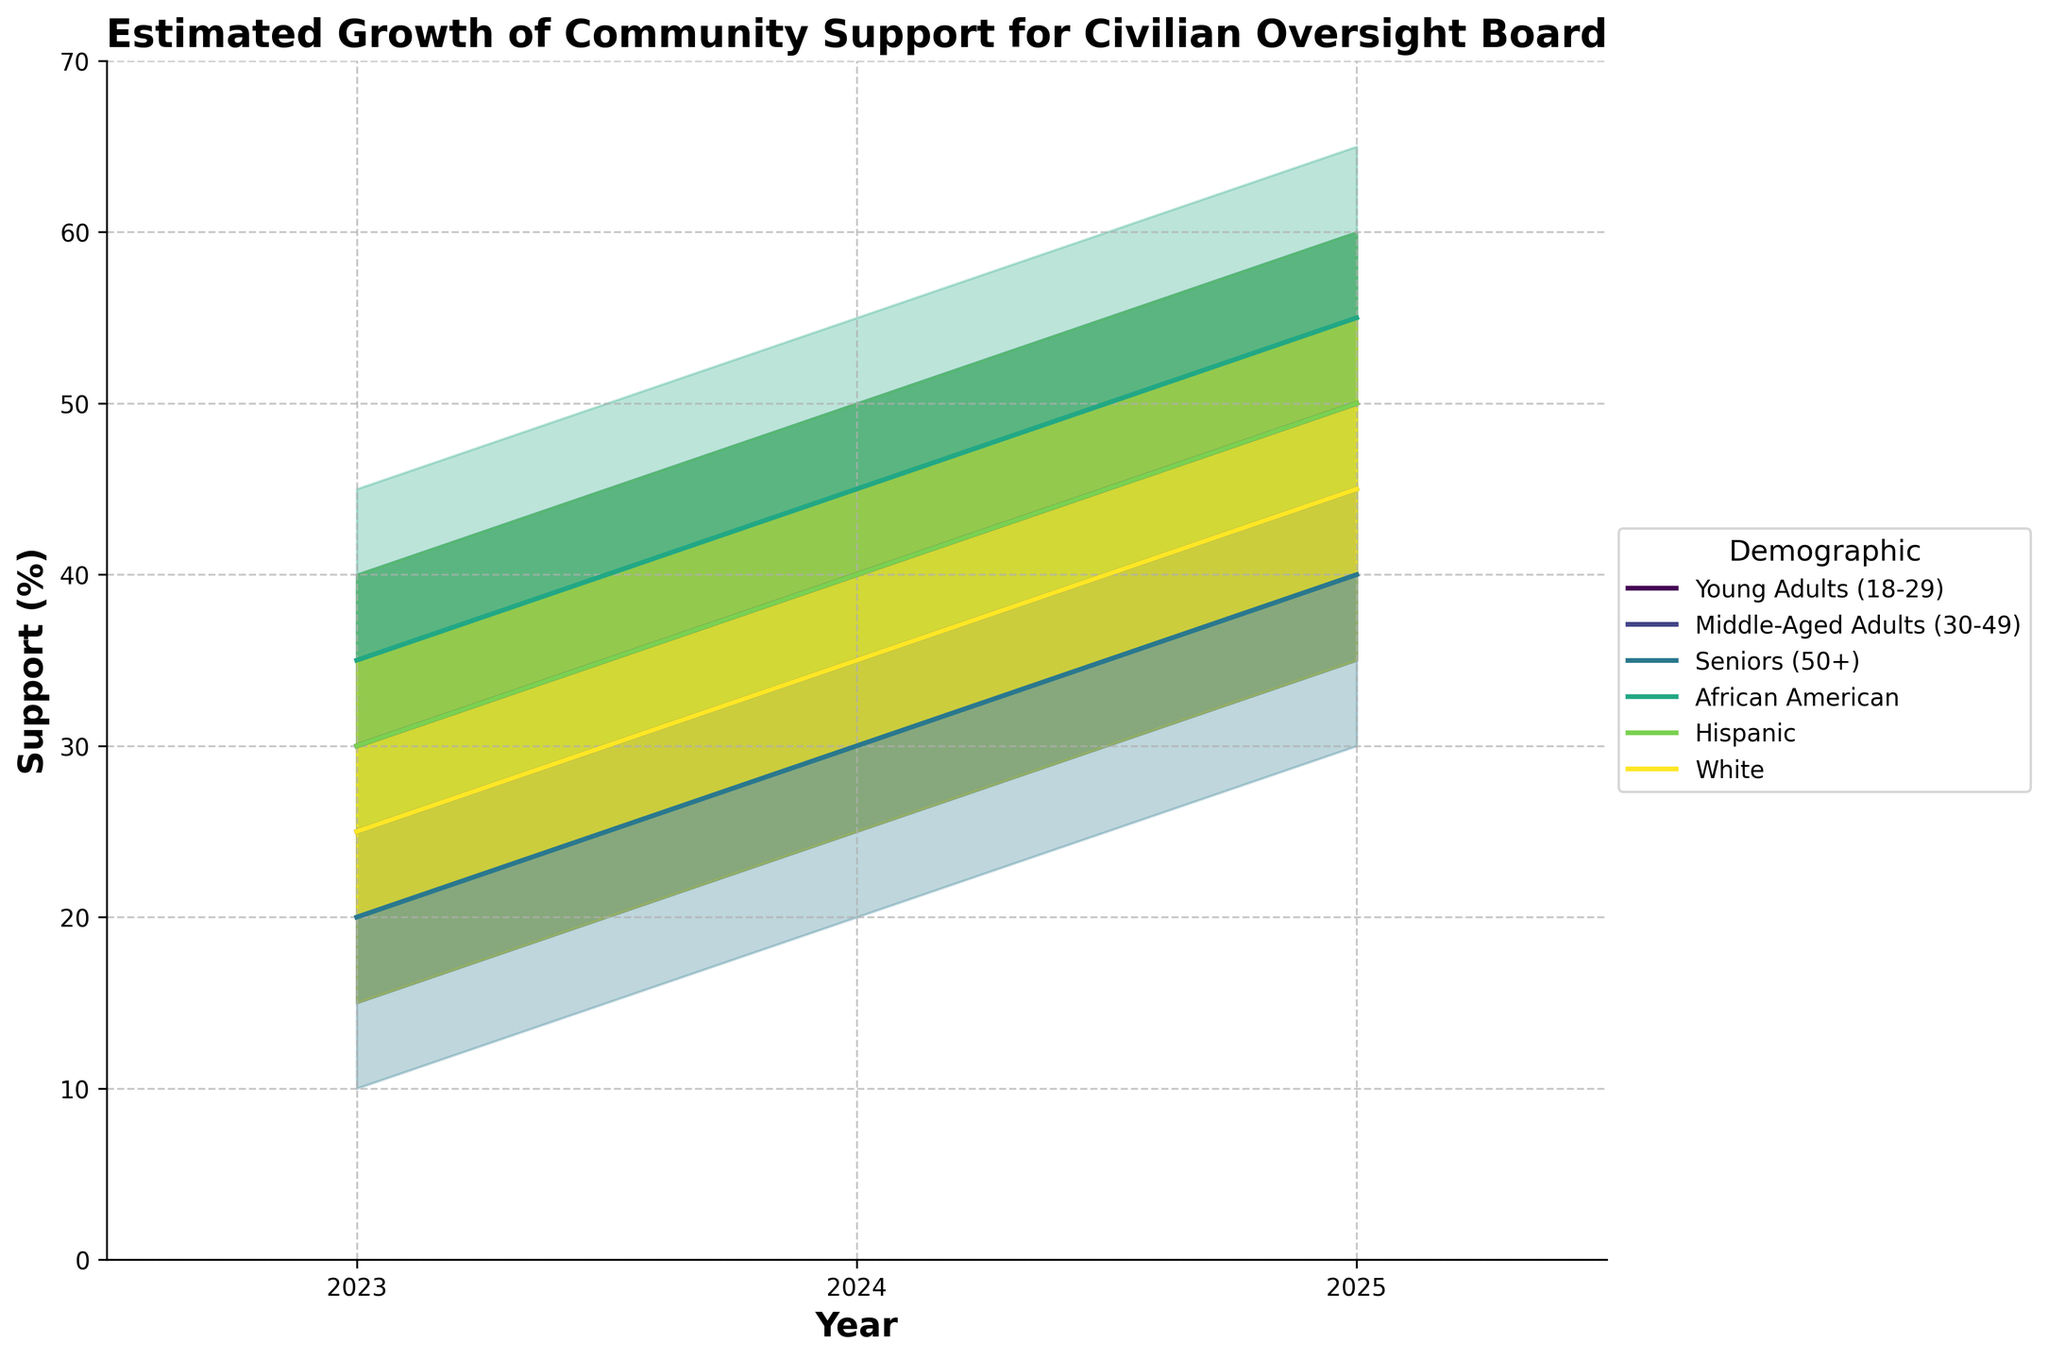What's the title of the chart? The title is a direct visual element often placed at the top of the chart in a larger font size to describe what the chart is about.
Answer: Estimated Growth of Community Support for Civilian Oversight Board What is the range for the support percentage on the y-axis? The y-axis displays the range of values for the support percentage. Checking the minimum and maximum values indicated on the y-axis, we see it ranges from the lowest point to the highest point.
Answer: 0 to 70 Which demographic group has the highest median support in 2025? To find this, look at the lines representing median values for each demographic group in 2025 and compare their values. The African American group has the highest median at 55%.
Answer: African American group What is the interquartile range (IQR) for Hispanic support in 2024? IQR is calculated by subtracting the first quartile (Q1) from the third quartile (Q3). For Hispanics in 2024, Q3 is 45% and Q1 is 35%, so the IQR is 45% - 35% = 10%.
Answer: 10% By how much does the support for Young Adults (18-29) increase from 2023 to 2025? Calculate the difference in the median support values for Young Adults between these years. In 2023, it is 30%, and in 2025 it is 50%, so the increase is 50% - 30% = 20%.
Answer: 20% Which demographic group has the lowest range of support estimates in 2023? The range is determined by subtracting the lowest estimated support from the highest for each group in 2023. Seniors (50+) have a range from 10% to 30%, giving a range of 20%, which is the smallest among all groups in that year.
Answer: Seniors (50+) Do any demographic groups show a declining trend in median support from 2023 to 2025? The trend of the median support line for each demographic group should be analyzed from 2023 to 2025. None of the median lines for any group show a decline in this period.
Answer: No How does the level of uncertainty for Middle-Aged Adults change from 2023 to 2025? The level of uncertainty can be gauged by the range (High - Low) for each year. For Middle-Aged Adults, in 2023 the range is 35% - 15% = 20%, and in 2025 it is 55% - 35% = 20%, showing no change.
Answer: No change Which demographic sees the fastest growth in median support? Comparing the growth in median support from 2023 to 2025 for all demographics, the Young Adults (18-29) increase from 30% to 50%, a rise of 20 percentage points—the fastest growth among all groups.
Answer: Young Adults (18-29) Between which years does the median support for the Hispanic demographic grow faster? Compare the increase in the median support values for Hispanic demographics between 2023 to 2024 and 2024 to 2025. From 2023 to 2024, it grows by 10 percentage points (30% to 40%), and from 2024 to 2025, it again grows by 10 percentage points (40% to 50%). The growth rate is the same in both intervals.
Answer: The rate is the same in both intervals (10 percentage points) 